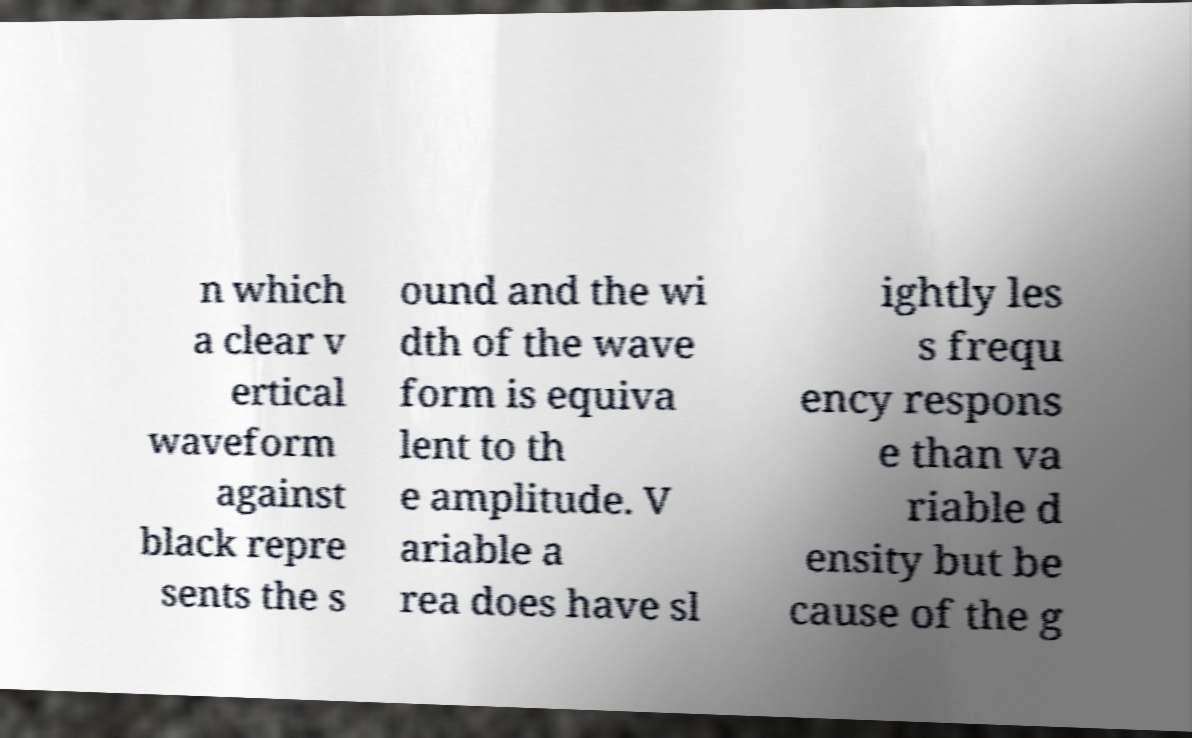I need the written content from this picture converted into text. Can you do that? n which a clear v ertical waveform against black repre sents the s ound and the wi dth of the wave form is equiva lent to th e amplitude. V ariable a rea does have sl ightly les s frequ ency respons e than va riable d ensity but be cause of the g 